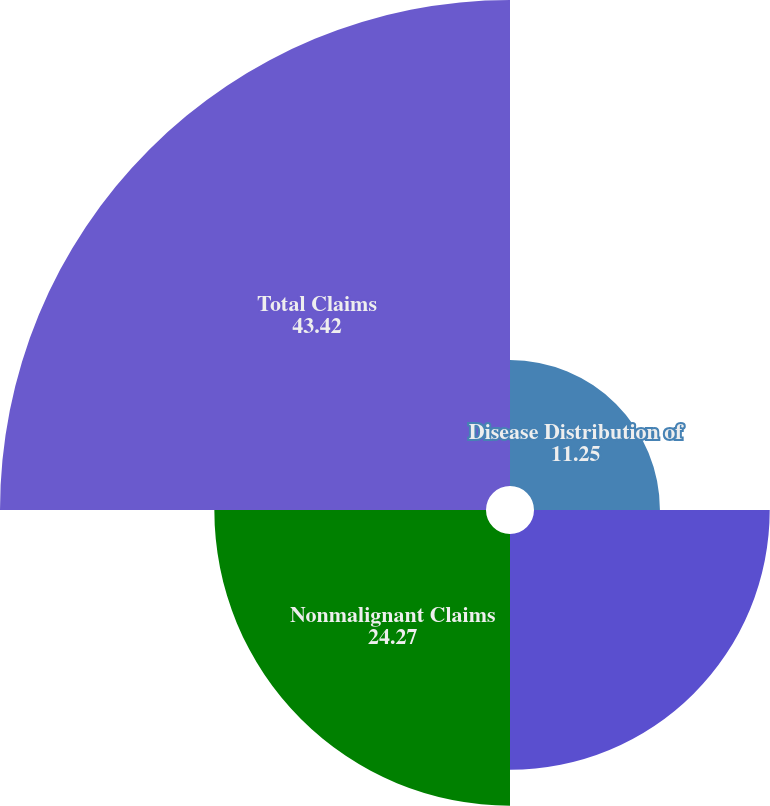Convert chart to OTSL. <chart><loc_0><loc_0><loc_500><loc_500><pie_chart><fcel>Disease Distribution of<fcel>Mesothelioma and Other Cancer<fcel>Nonmalignant Claims<fcel>Total Claims<nl><fcel>11.25%<fcel>21.06%<fcel>24.27%<fcel>43.42%<nl></chart> 